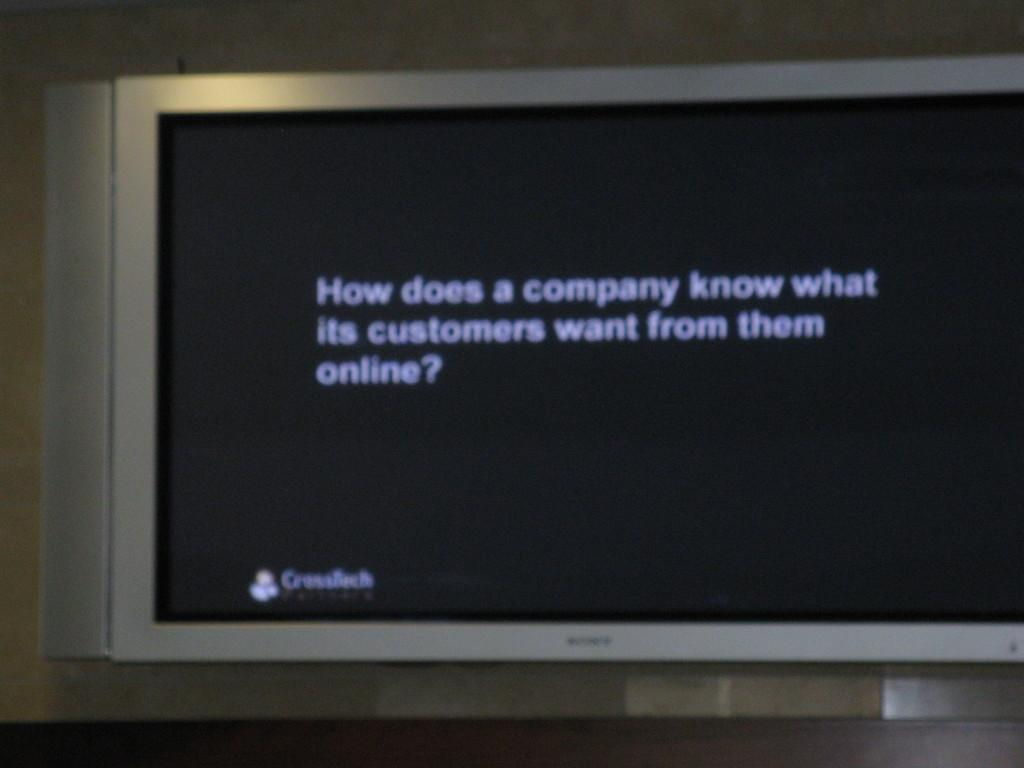<image>
Give a short and clear explanation of the subsequent image. A monitor displays a question of, "How does a company know what its customers want from them online. 